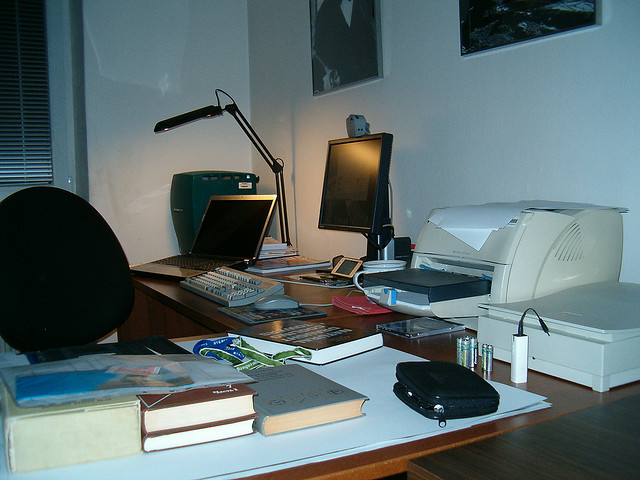<image>What kind of business is going on at this premises? I am not sure what kind of business is going on at this premises. It could be office work, accounting, tutoring, or even a lawyer's office. What kind of business is going on at this premises? I am not sure what kind of business is going on at this premises. It can be office work, accounting, tutoring, or other activities. 